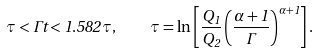Convert formula to latex. <formula><loc_0><loc_0><loc_500><loc_500>\tau < \Gamma t < 1 . 5 8 2 \tau , \quad \tau = \ln \left [ \frac { Q _ { 1 } } { Q _ { 2 } } \left ( \frac { \alpha + 1 } \Gamma \right ) ^ { \alpha + 1 } \right ] .</formula> 